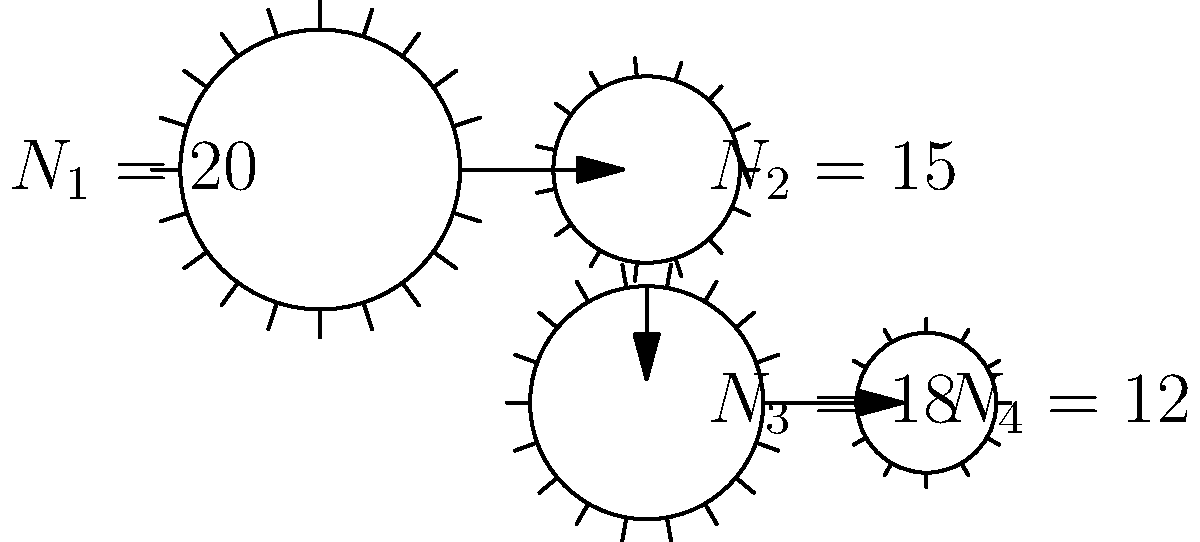In a multi-stage gearbox system used for a microscope focus adjustment mechanism, there are four gears arranged as shown in the diagram. The number of teeth for each gear is given: $N_1 = 20$, $N_2 = 15$, $N_3 = 18$, and $N_4 = 12$. If the input gear ($N_1$) rotates at 300 rpm, what is the output speed of the final gear ($N_4$) in rpm? To solve this problem, we need to calculate the gear ratio for each stage and then determine the overall gear ratio of the system. Let's approach this step-by-step:

1. Calculate the gear ratio for the first stage (between $N_1$ and $N_2$):
   $$\text{Ratio}_1 = \frac{N_2}{N_1} = \frac{15}{20} = 0.75$$

2. Calculate the gear ratio for the second stage (between $N_3$ and $N_4$):
   $$\text{Ratio}_2 = \frac{N_4}{N_3} = \frac{12}{18} = \frac{2}{3} \approx 0.6667$$

3. The overall gear ratio is the product of these two ratios:
   $$\text{Ratio}_{\text{total}} = \text{Ratio}_1 \times \text{Ratio}_2 = 0.75 \times \frac{2}{3} = 0.5$$

4. To find the output speed, multiply the input speed by the overall gear ratio:
   $$\text{Output Speed} = \text{Input Speed} \times \text{Ratio}_{\text{total}}$$
   $$\text{Output Speed} = 300 \text{ rpm} \times 0.5 = 150 \text{ rpm}$$

Therefore, when the input gear rotates at 300 rpm, the output gear will rotate at 150 rpm.
Answer: 150 rpm 